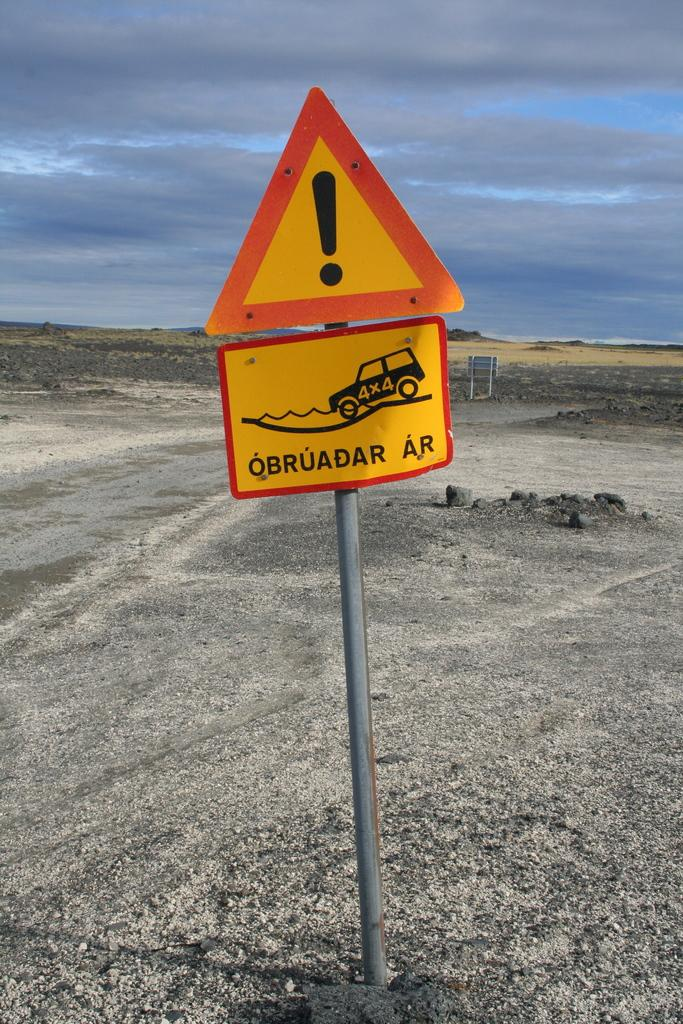<image>
Create a compact narrative representing the image presented. A red and yellow sign at bottom with the word obruadar ar at the bottom. 